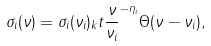<formula> <loc_0><loc_0><loc_500><loc_500>\sigma _ { i } ( \nu ) = \sigma _ { i } ( \nu _ { i } ) _ { k } t { \frac { \nu } { \nu _ { i } } } ^ { - \eta _ { i } } \Theta ( \nu - \nu _ { i } ) ,</formula> 